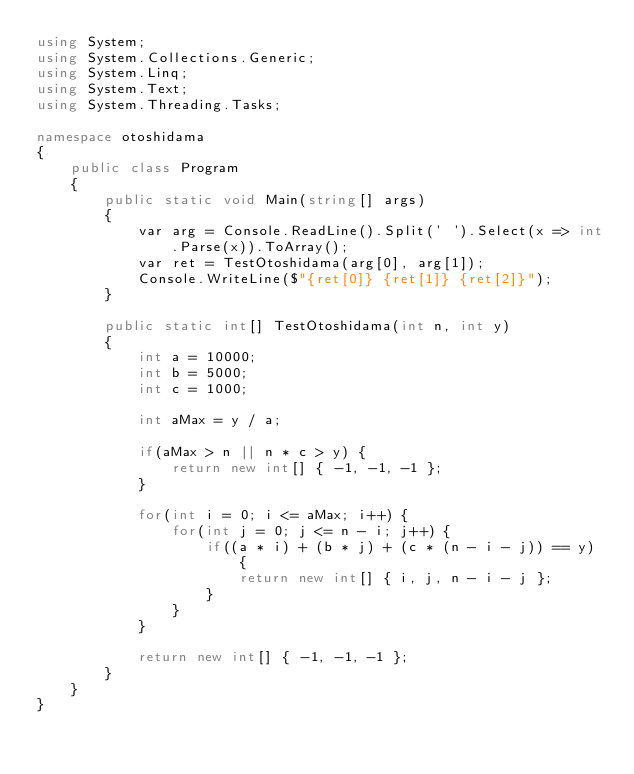<code> <loc_0><loc_0><loc_500><loc_500><_C#_>using System;
using System.Collections.Generic;
using System.Linq;
using System.Text;
using System.Threading.Tasks;

namespace otoshidama
{
	public class Program
	{
		public static void Main(string[] args)
		{
			var arg = Console.ReadLine().Split(' ').Select(x => int.Parse(x)).ToArray();
			var ret = TestOtoshidama(arg[0], arg[1]);
			Console.WriteLine($"{ret[0]} {ret[1]} {ret[2]}");
		}

		public static int[] TestOtoshidama(int n, int y)
		{
			int a = 10000;
			int b = 5000;
			int c = 1000;

			int aMax = y / a;

			if(aMax > n || n * c > y) {
				return new int[] { -1, -1, -1 };
			}

			for(int i = 0; i <= aMax; i++) {
				for(int j = 0; j <= n - i; j++) {
					if((a * i) + (b * j) + (c * (n - i - j)) == y) {
						return new int[] { i, j, n - i - j };
					}
				}
			}

			return new int[] { -1, -1, -1 };
		}
	}
}
</code> 